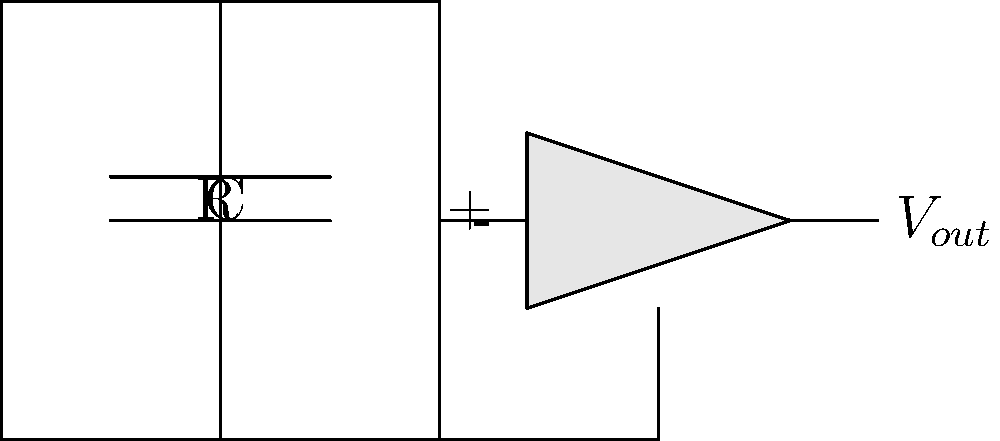In the basic analog synthesizer oscillator circuit shown above, which component primarily determines the frequency of oscillation, and how would you modify it to create a pitch-bending effect often used in electronic music? To understand this circuit and answer the question, let's break it down step-by-step:

1. The circuit shown is a basic RC oscillator, commonly used in analog synthesizers.

2. The main components that determine the frequency of oscillation are the resistor (R) and capacitor (C) in the feedback loop.

3. The frequency of oscillation is given by the formula:

   $$f = \frac{1}{2\pi RC}$$

4. To create a pitch-bending effect, we need to be able to change the frequency of oscillation in real-time.

5. Since the frequency is inversely proportional to R and C, we can change either of these components to alter the pitch.

6. In practice, it's easier to vary the resistance rather than the capacitance.

7. To create a pitch-bending effect, we would replace the fixed resistor (R) with a variable resistor or potentiometer.

8. By adjusting the potentiometer, we can smoothly change the resistance, which in turn changes the frequency of oscillation, creating the pitch-bend effect.

9. This modification allows the musician to continuously vary the pitch, which is a common technique in electronic and goth-rock music, genres popular in the Russian electronic music scene.
Answer: Replace the fixed resistor (R) with a potentiometer. 